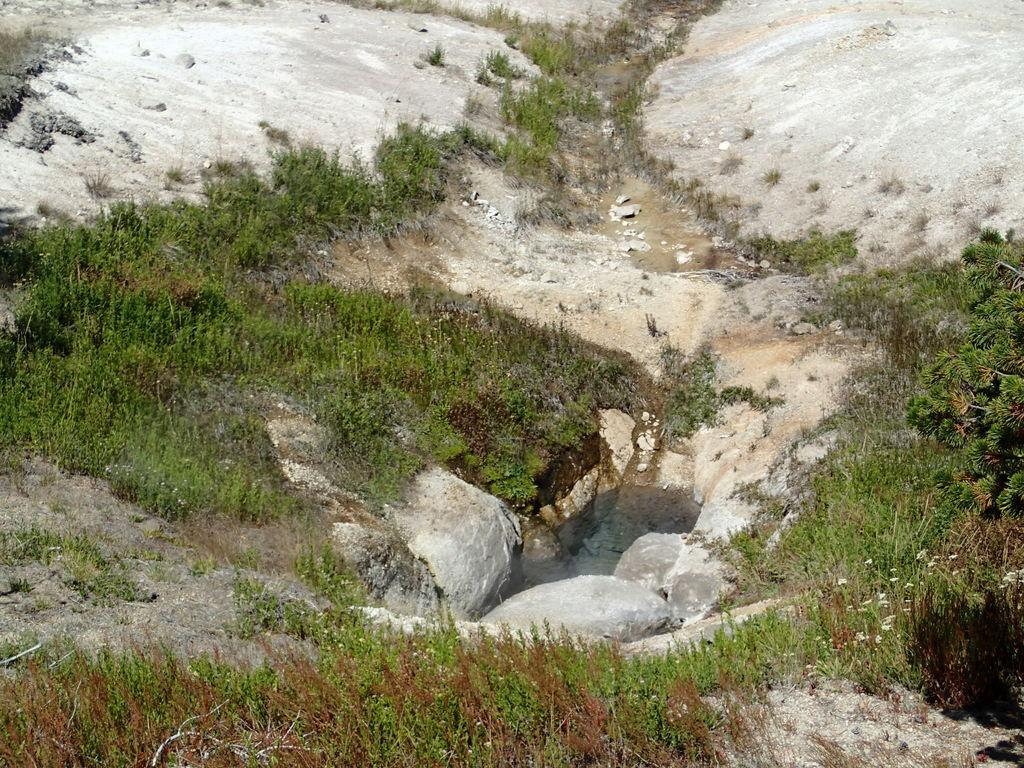What is the primary element visible in the image? There is: There is water in the image. What other objects or features can be seen in the image? There are rocks and plants in the image. What type of produce is being harvested by the lawyer in the image? There is no produce or lawyer present in the image; it features water, rocks, and plants. 